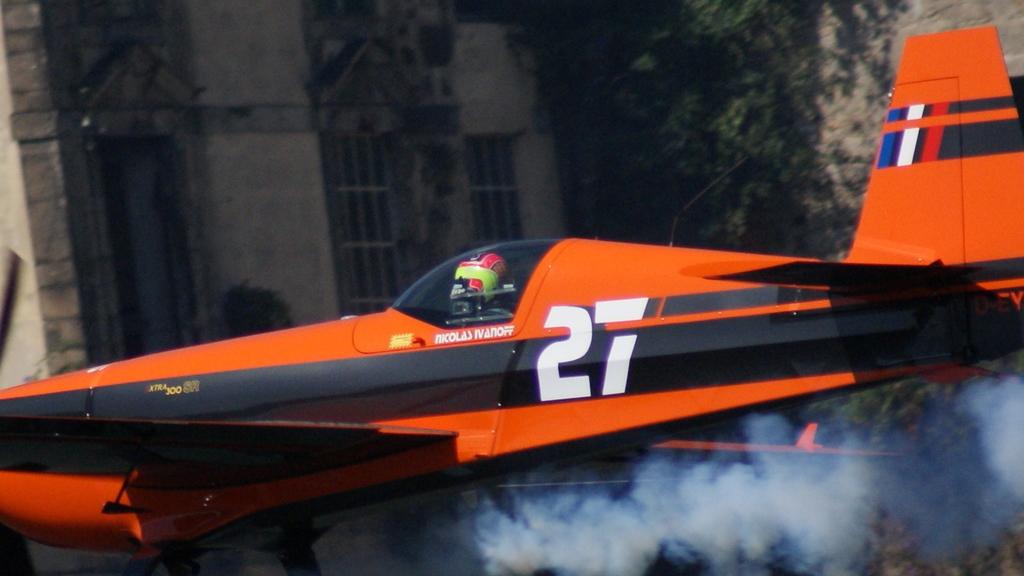What number is on the side of the plane?
Provide a succinct answer. 27. Whose name is written on the plane?
Make the answer very short. Nicolas ivanoff. 